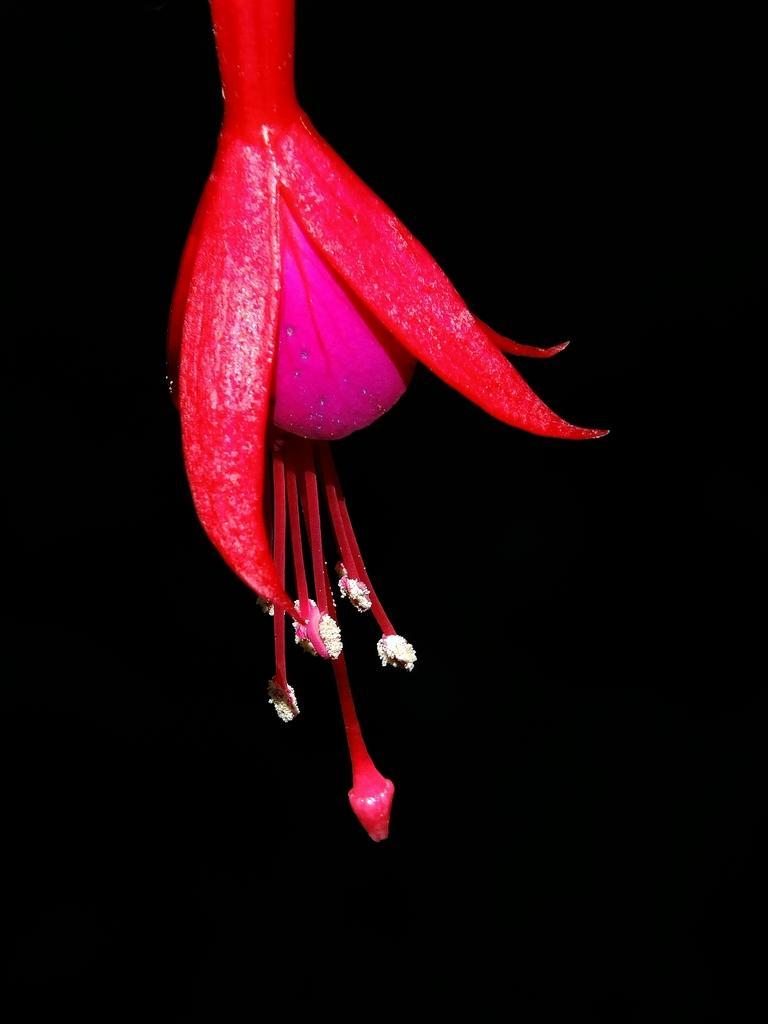Describe this image in one or two sentences. In this image we can see a flower and a dark background. 